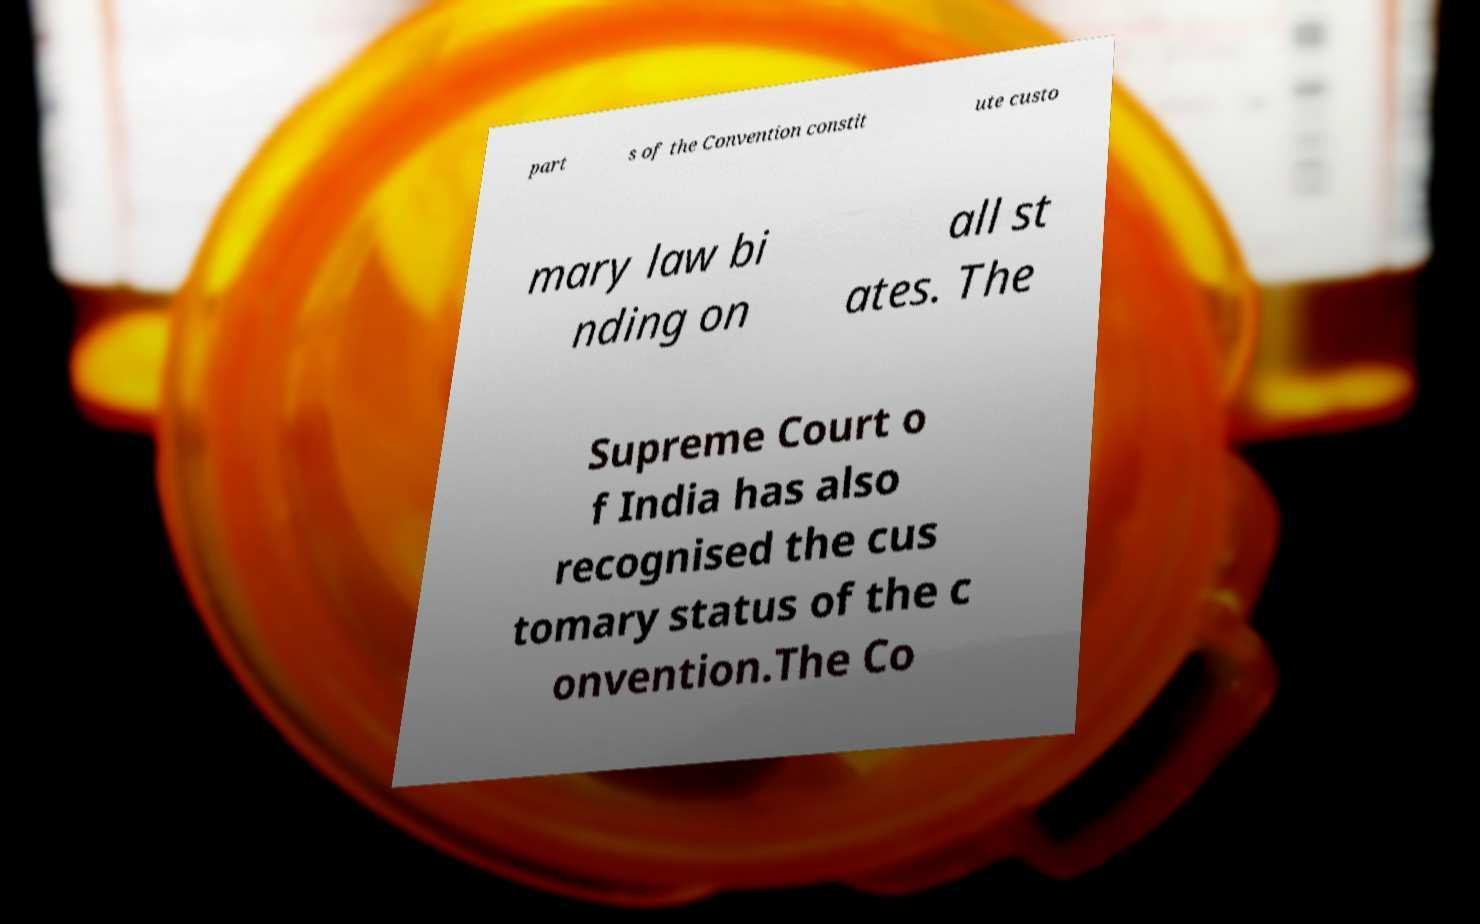There's text embedded in this image that I need extracted. Can you transcribe it verbatim? part s of the Convention constit ute custo mary law bi nding on all st ates. The Supreme Court o f India has also recognised the cus tomary status of the c onvention.The Co 